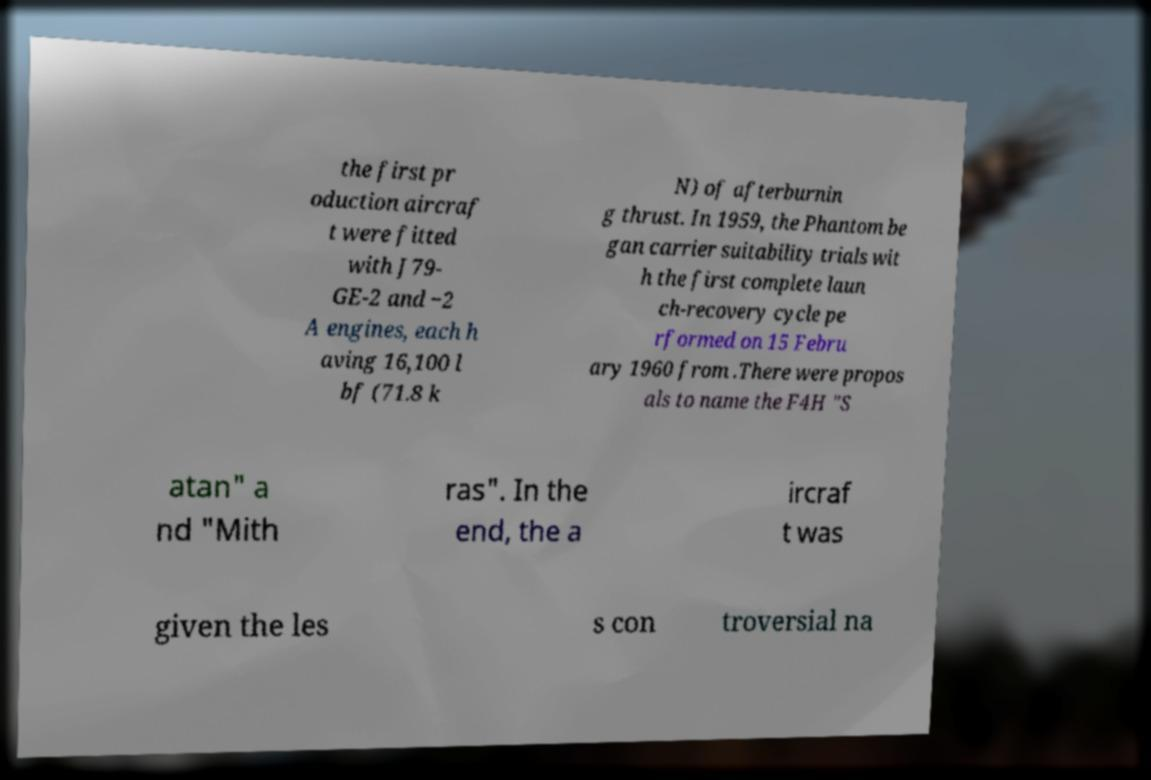Can you read and provide the text displayed in the image?This photo seems to have some interesting text. Can you extract and type it out for me? the first pr oduction aircraf t were fitted with J79- GE-2 and −2 A engines, each h aving 16,100 l bf (71.8 k N) of afterburnin g thrust. In 1959, the Phantom be gan carrier suitability trials wit h the first complete laun ch-recovery cycle pe rformed on 15 Febru ary 1960 from .There were propos als to name the F4H "S atan" a nd "Mith ras". In the end, the a ircraf t was given the les s con troversial na 